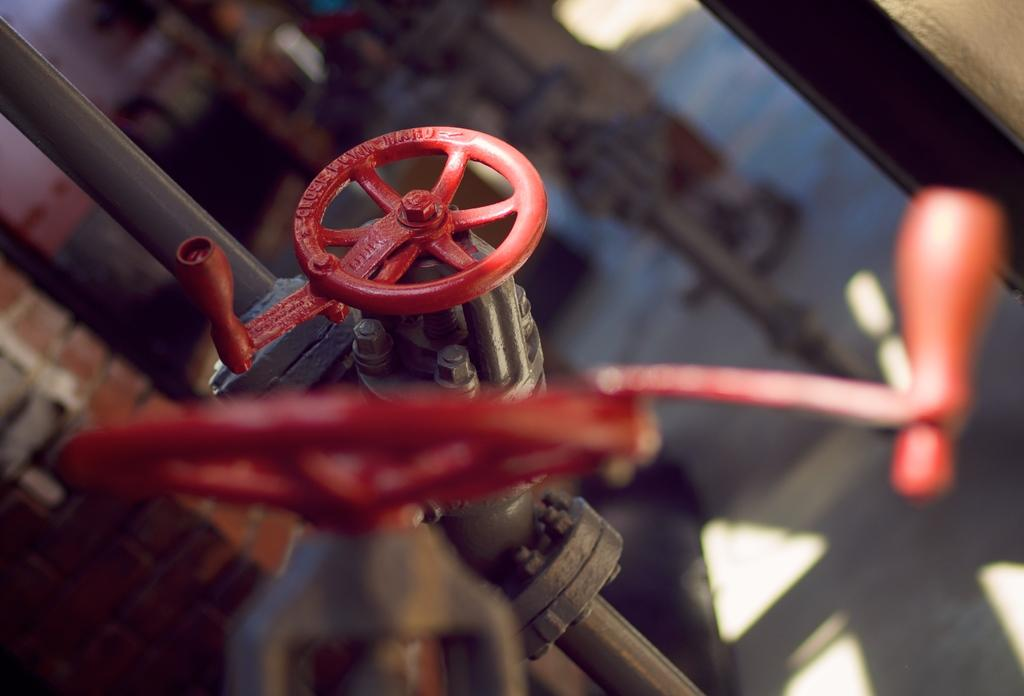What color are the taps in the image? The taps in the image are red. How are the taps attached to the pipe? The taps are fixed to a pipe. What part of the image is blurred? The part of the image with the taps and the background of the image are blurred. What type of sofa can be seen in the image? There is no sofa present in the image. What is the weather like in the sky shown in the image? There is no sky visible in the image, as the background is blurred. 